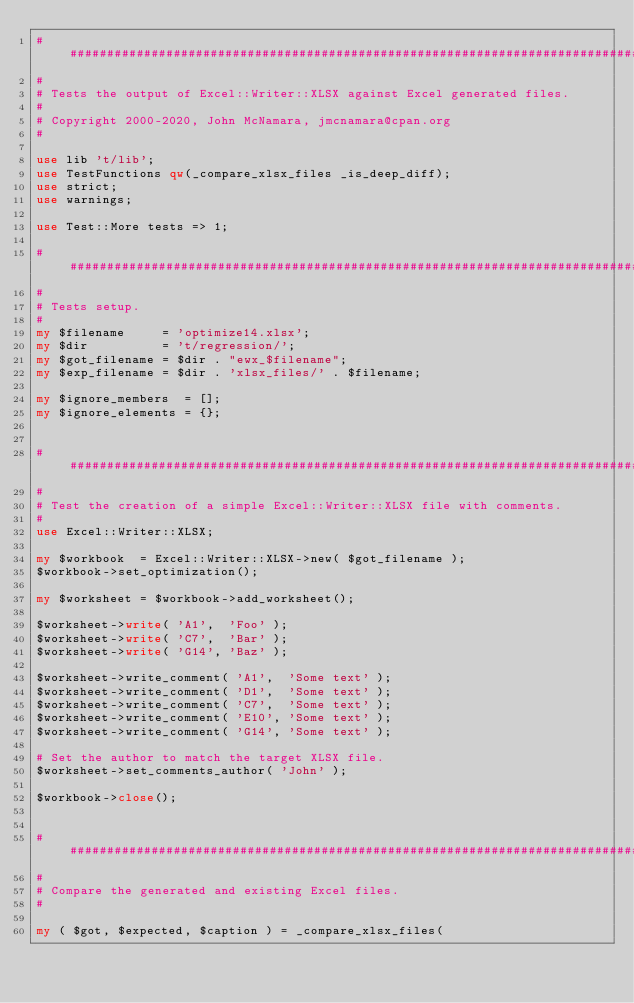Convert code to text. <code><loc_0><loc_0><loc_500><loc_500><_Perl_>###############################################################################
#
# Tests the output of Excel::Writer::XLSX against Excel generated files.
#
# Copyright 2000-2020, John McNamara, jmcnamara@cpan.org
#

use lib 't/lib';
use TestFunctions qw(_compare_xlsx_files _is_deep_diff);
use strict;
use warnings;

use Test::More tests => 1;

###############################################################################
#
# Tests setup.
#
my $filename     = 'optimize14.xlsx';
my $dir          = 't/regression/';
my $got_filename = $dir . "ewx_$filename";
my $exp_filename = $dir . 'xlsx_files/' . $filename;

my $ignore_members  = [];
my $ignore_elements = {};


###############################################################################
#
# Test the creation of a simple Excel::Writer::XLSX file with comments.
#
use Excel::Writer::XLSX;

my $workbook  = Excel::Writer::XLSX->new( $got_filename );
$workbook->set_optimization();

my $worksheet = $workbook->add_worksheet();

$worksheet->write( 'A1',  'Foo' );
$worksheet->write( 'C7',  'Bar' );
$worksheet->write( 'G14', 'Baz' );

$worksheet->write_comment( 'A1',  'Some text' );
$worksheet->write_comment( 'D1',  'Some text' );
$worksheet->write_comment( 'C7',  'Some text' );
$worksheet->write_comment( 'E10', 'Some text' );
$worksheet->write_comment( 'G14', 'Some text' );

# Set the author to match the target XLSX file.
$worksheet->set_comments_author( 'John' );

$workbook->close();


###############################################################################
#
# Compare the generated and existing Excel files.
#

my ( $got, $expected, $caption ) = _compare_xlsx_files(
</code> 